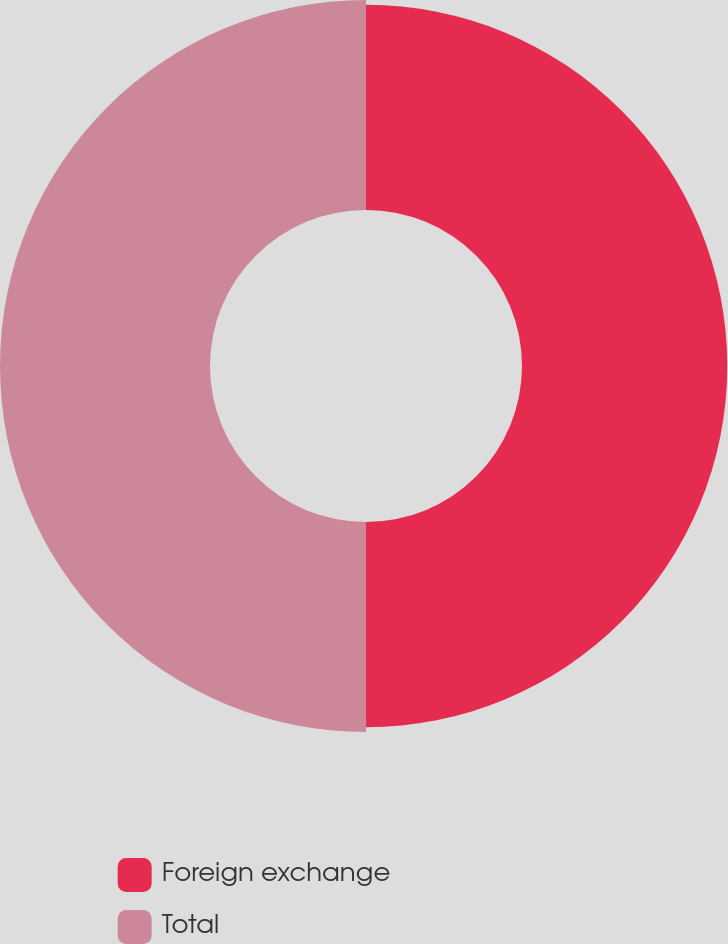<chart> <loc_0><loc_0><loc_500><loc_500><pie_chart><fcel>Foreign exchange<fcel>Total<nl><fcel>49.43%<fcel>50.57%<nl></chart> 